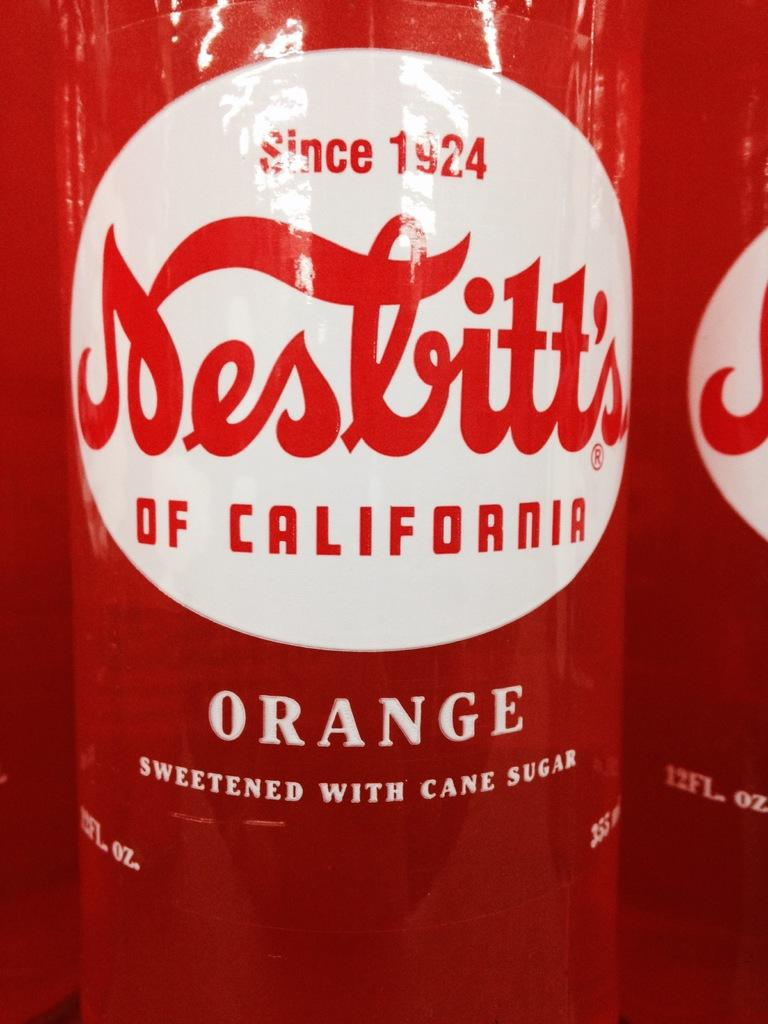Provide a one-sentence caption for the provided image. bottle of orange soda from California are un opened. 